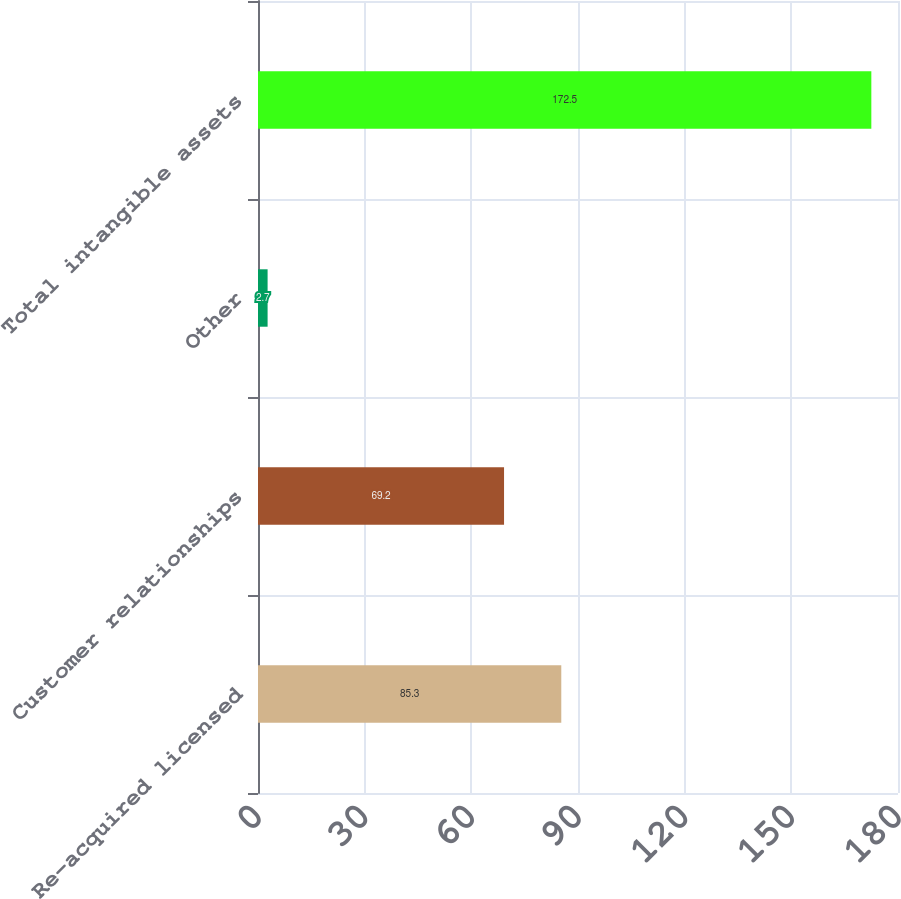Convert chart to OTSL. <chart><loc_0><loc_0><loc_500><loc_500><bar_chart><fcel>Re-acquired licensed<fcel>Customer relationships<fcel>Other<fcel>Total intangible assets<nl><fcel>85.3<fcel>69.2<fcel>2.7<fcel>172.5<nl></chart> 